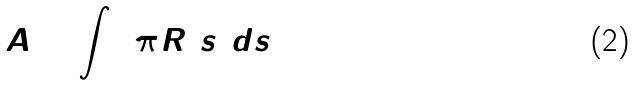<formula> <loc_0><loc_0><loc_500><loc_500>A = \int 2 \pi R ( s ) d s</formula> 